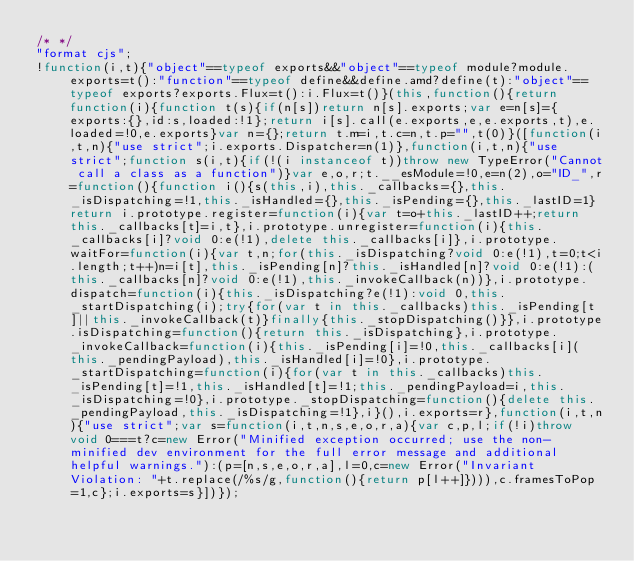<code> <loc_0><loc_0><loc_500><loc_500><_JavaScript_>/* */ 
"format cjs";
!function(i,t){"object"==typeof exports&&"object"==typeof module?module.exports=t():"function"==typeof define&&define.amd?define(t):"object"==typeof exports?exports.Flux=t():i.Flux=t()}(this,function(){return function(i){function t(s){if(n[s])return n[s].exports;var e=n[s]={exports:{},id:s,loaded:!1};return i[s].call(e.exports,e,e.exports,t),e.loaded=!0,e.exports}var n={};return t.m=i,t.c=n,t.p="",t(0)}([function(i,t,n){"use strict";i.exports.Dispatcher=n(1)},function(i,t,n){"use strict";function s(i,t){if(!(i instanceof t))throw new TypeError("Cannot call a class as a function")}var e,o,r;t.__esModule=!0,e=n(2),o="ID_",r=function(){function i(){s(this,i),this._callbacks={},this._isDispatching=!1,this._isHandled={},this._isPending={},this._lastID=1}return i.prototype.register=function(i){var t=o+this._lastID++;return this._callbacks[t]=i,t},i.prototype.unregister=function(i){this._callbacks[i]?void 0:e(!1),delete this._callbacks[i]},i.prototype.waitFor=function(i){var t,n;for(this._isDispatching?void 0:e(!1),t=0;t<i.length;t++)n=i[t],this._isPending[n]?this._isHandled[n]?void 0:e(!1):(this._callbacks[n]?void 0:e(!1),this._invokeCallback(n))},i.prototype.dispatch=function(i){this._isDispatching?e(!1):void 0,this._startDispatching(i);try{for(var t in this._callbacks)this._isPending[t]||this._invokeCallback(t)}finally{this._stopDispatching()}},i.prototype.isDispatching=function(){return this._isDispatching},i.prototype._invokeCallback=function(i){this._isPending[i]=!0,this._callbacks[i](this._pendingPayload),this._isHandled[i]=!0},i.prototype._startDispatching=function(i){for(var t in this._callbacks)this._isPending[t]=!1,this._isHandled[t]=!1;this._pendingPayload=i,this._isDispatching=!0},i.prototype._stopDispatching=function(){delete this._pendingPayload,this._isDispatching=!1},i}(),i.exports=r},function(i,t,n){"use strict";var s=function(i,t,n,s,e,o,r,a){var c,p,l;if(!i)throw void 0===t?c=new Error("Minified exception occurred; use the non-minified dev environment for the full error message and additional helpful warnings."):(p=[n,s,e,o,r,a],l=0,c=new Error("Invariant Violation: "+t.replace(/%s/g,function(){return p[l++]}))),c.framesToPop=1,c};i.exports=s}])});</code> 